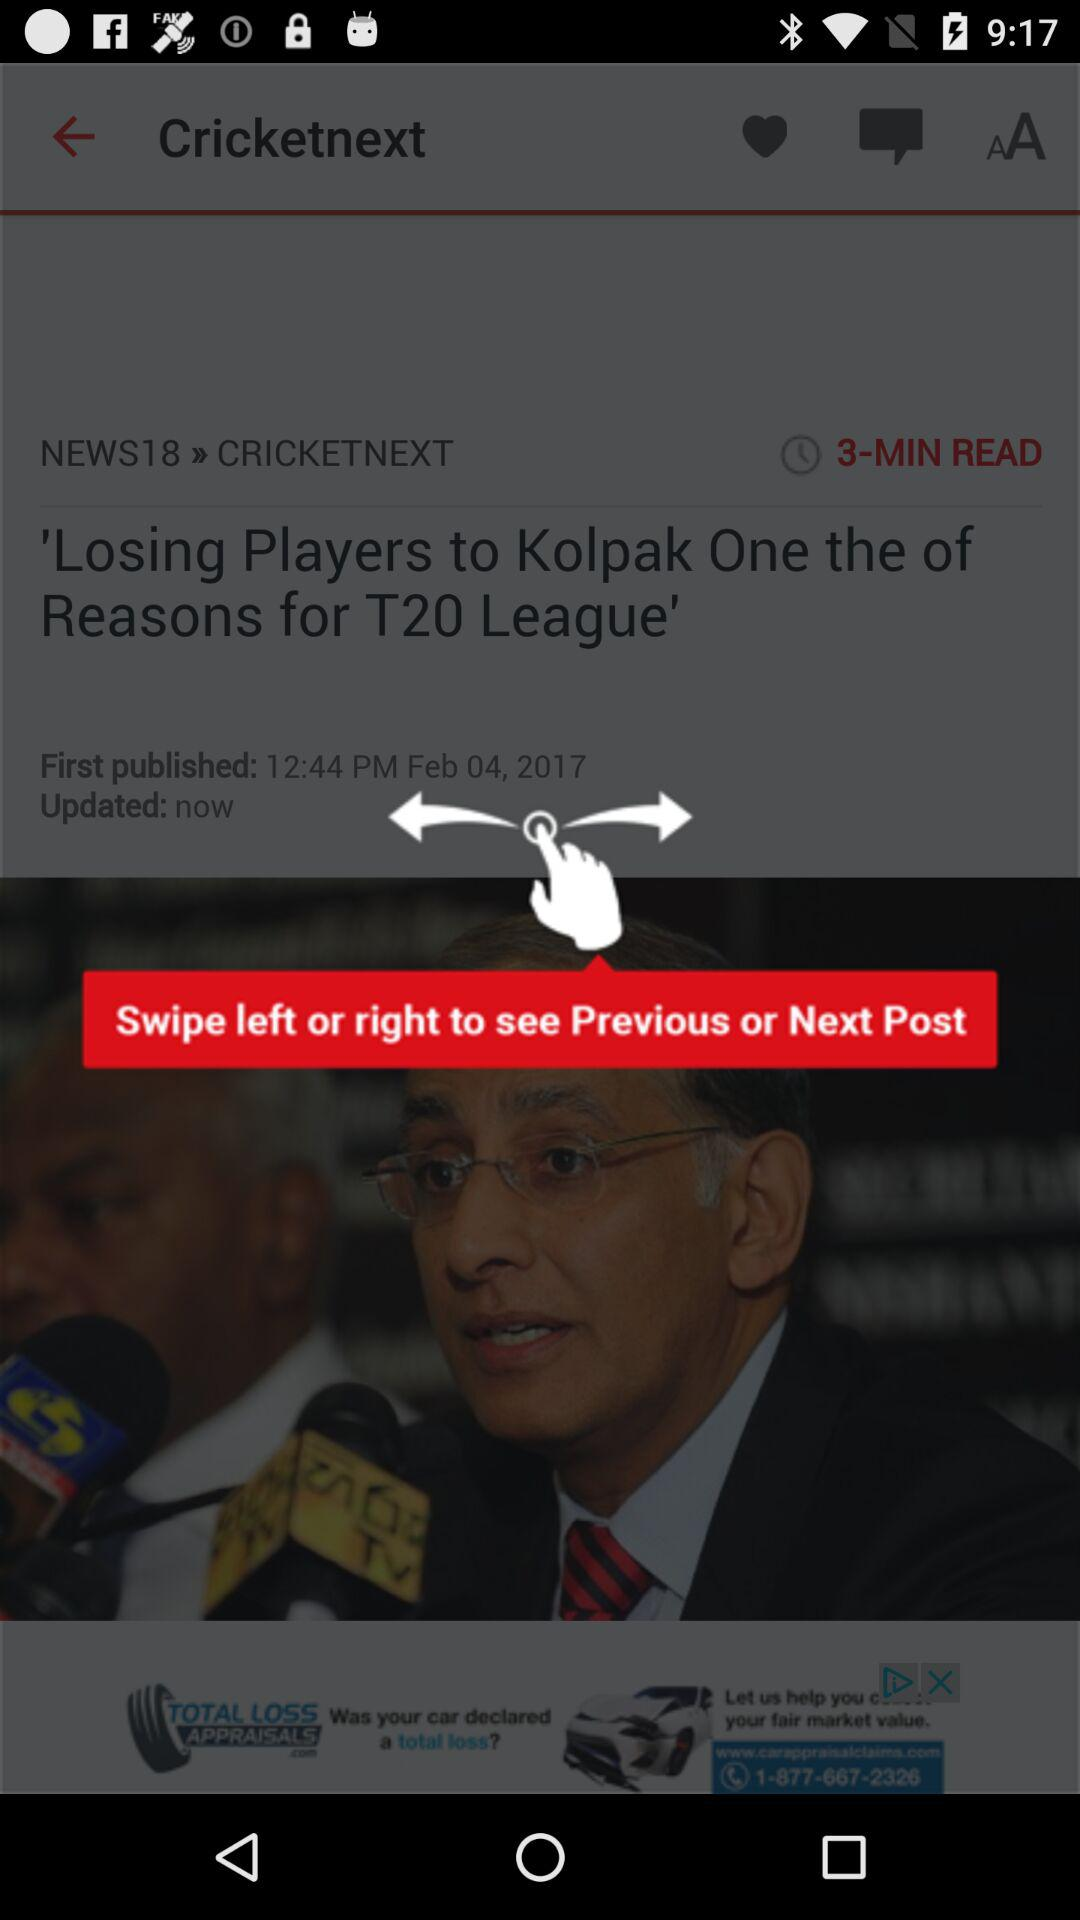When was the article updated? The article was updated just now. 